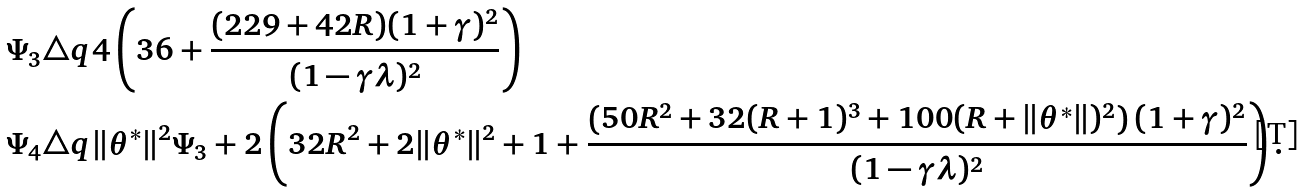<formula> <loc_0><loc_0><loc_500><loc_500>& \Psi _ { 3 } \triangle q 4 \left ( 3 6 + \frac { ( 2 2 9 + 4 2 R ) ( 1 + \gamma ) ^ { 2 } } { ( 1 - \gamma \lambda ) ^ { 2 } } \right ) \\ & \Psi _ { 4 } \triangle q \| \theta ^ { * } \| ^ { 2 } \Psi _ { 3 } + 2 \left ( 3 2 R ^ { 2 } + 2 \| \theta ^ { * } \| ^ { 2 } + 1 + \frac { \left ( 5 0 R ^ { 2 } + 3 2 ( R + 1 ) ^ { 3 } + 1 0 0 ( R + \| \theta ^ { * } \| ) ^ { 2 } \right ) ( 1 + \gamma ) ^ { 2 } } { ( 1 - \gamma \lambda ) ^ { 2 } } \right ) .</formula> 